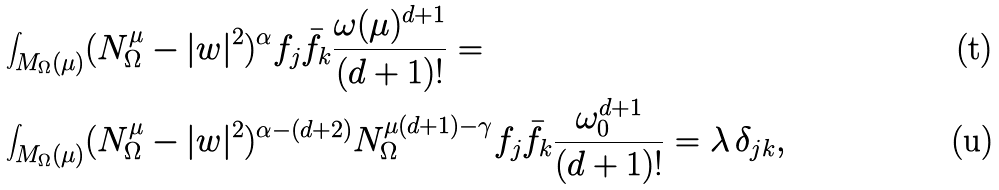Convert formula to latex. <formula><loc_0><loc_0><loc_500><loc_500>& \int _ { M _ { \Omega } ( \mu ) } ( N ^ { \mu } _ { \Omega } - | w | ^ { 2 } ) ^ { \alpha } f _ { j } \bar { f } _ { k } \frac { \omega ( \mu ) ^ { d + 1 } } { ( d + 1 ) ! } = \\ & \int _ { M _ { \Omega } ( \mu ) } ( N ^ { \mu } _ { \Omega } - | w | ^ { 2 } ) ^ { \alpha - ( d + 2 ) } N _ { \Omega } ^ { \mu ( d + 1 ) - \gamma } f _ { j } \bar { f } _ { k } \frac { \omega _ { 0 } ^ { d + 1 } } { ( d + 1 ) ! } = \lambda \, \delta _ { j k } ,</formula> 